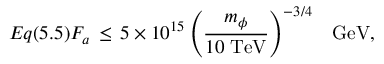<formula> <loc_0><loc_0><loc_500><loc_500>E q ( 5 . 5 ) F _ { a } \, \leq \, 5 \times 1 0 ^ { 1 5 } \left ( \frac { m _ { \phi } } { 1 0 \, T e V } \right ) ^ { - 3 / 4 } \, G e V ,</formula> 